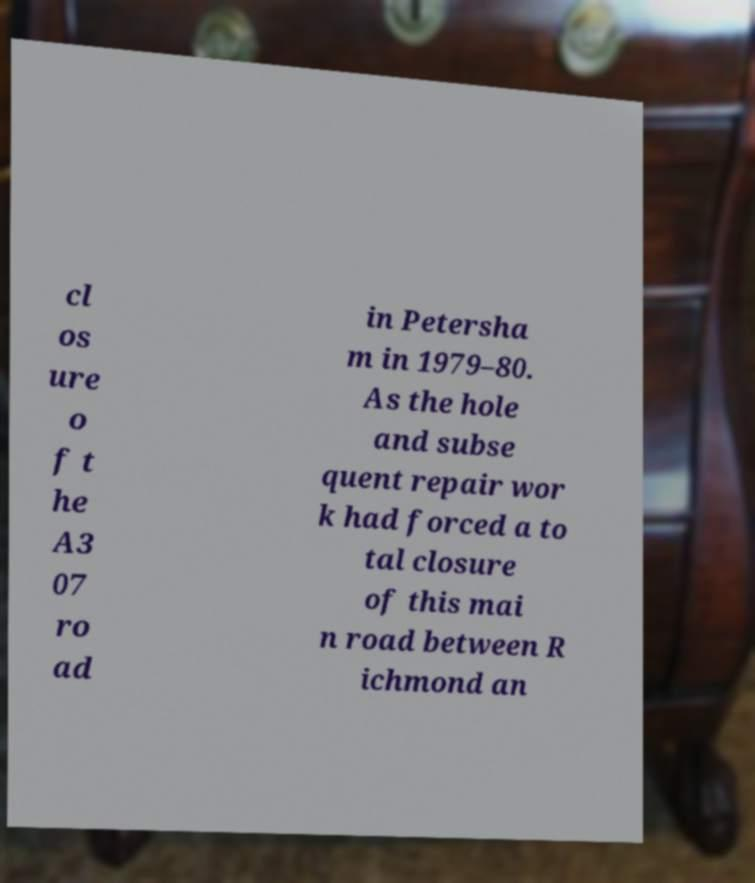Please read and relay the text visible in this image. What does it say? cl os ure o f t he A3 07 ro ad in Petersha m in 1979–80. As the hole and subse quent repair wor k had forced a to tal closure of this mai n road between R ichmond an 